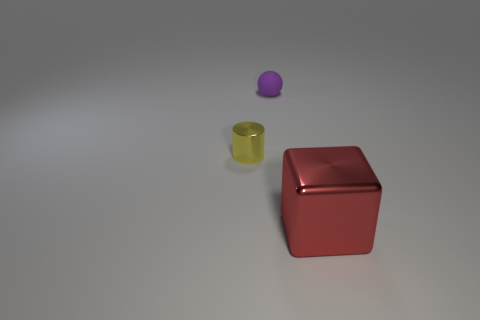Is the number of cyan rubber balls less than the number of things?
Offer a terse response. Yes. There is a metal thing behind the metal cube; is its color the same as the big shiny object?
Make the answer very short. No. What is the color of the small thing that is made of the same material as the red block?
Make the answer very short. Yellow. Is the size of the purple rubber sphere the same as the yellow shiny object?
Your response must be concise. Yes. What is the material of the cylinder?
Keep it short and to the point. Metal. There is a sphere that is the same size as the yellow object; what material is it?
Your answer should be compact. Rubber. Are there any other metallic blocks of the same size as the red cube?
Give a very brief answer. No. Are there the same number of large red metal blocks that are to the left of the large metal cube and large red metal objects behind the tiny purple matte object?
Ensure brevity in your answer.  Yes. Is the number of small red metallic balls greater than the number of matte spheres?
Offer a terse response. No. How many shiny objects are either large red cubes or big gray things?
Keep it short and to the point. 1. 